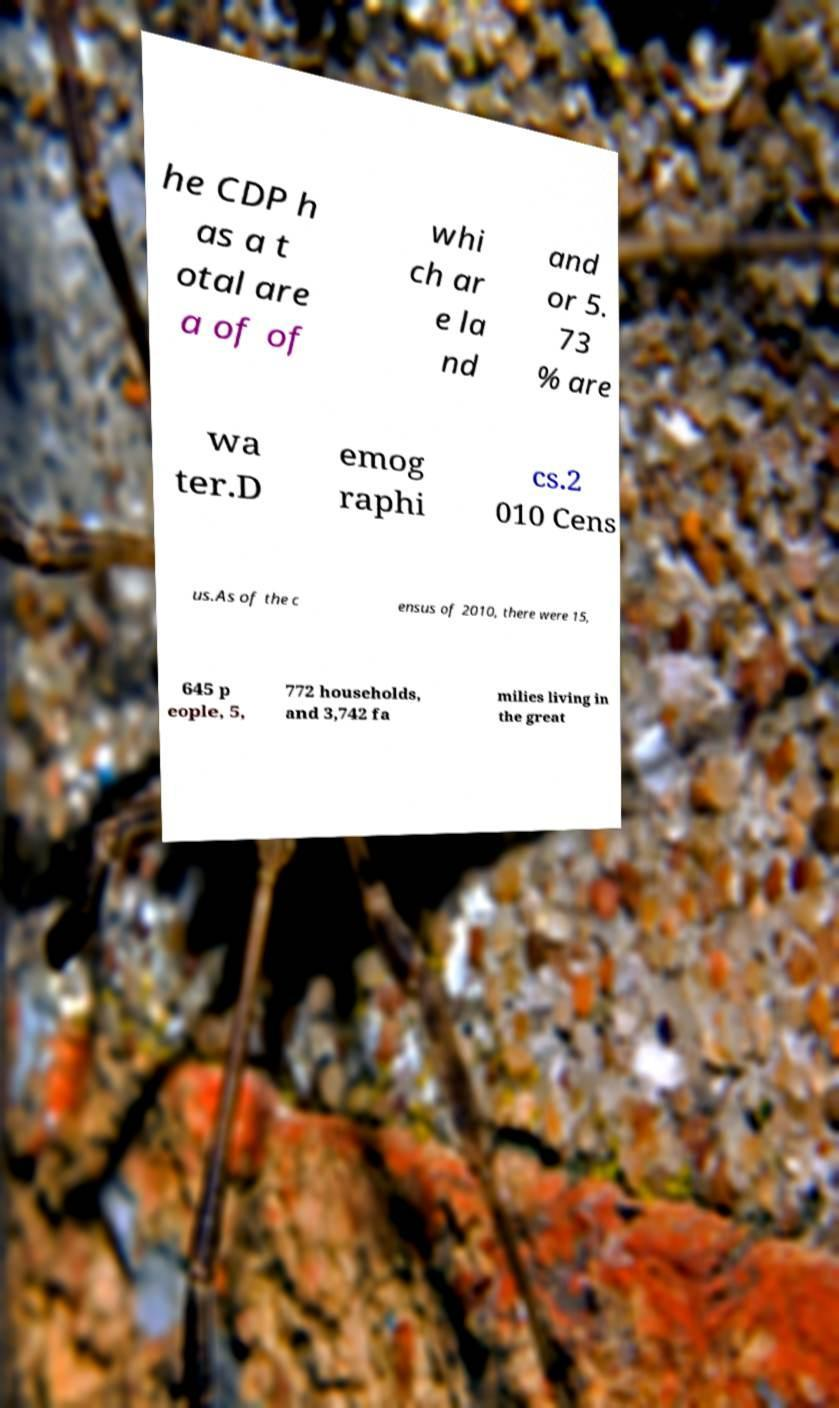There's text embedded in this image that I need extracted. Can you transcribe it verbatim? he CDP h as a t otal are a of of whi ch ar e la nd and or 5. 73 % are wa ter.D emog raphi cs.2 010 Cens us.As of the c ensus of 2010, there were 15, 645 p eople, 5, 772 households, and 3,742 fa milies living in the great 